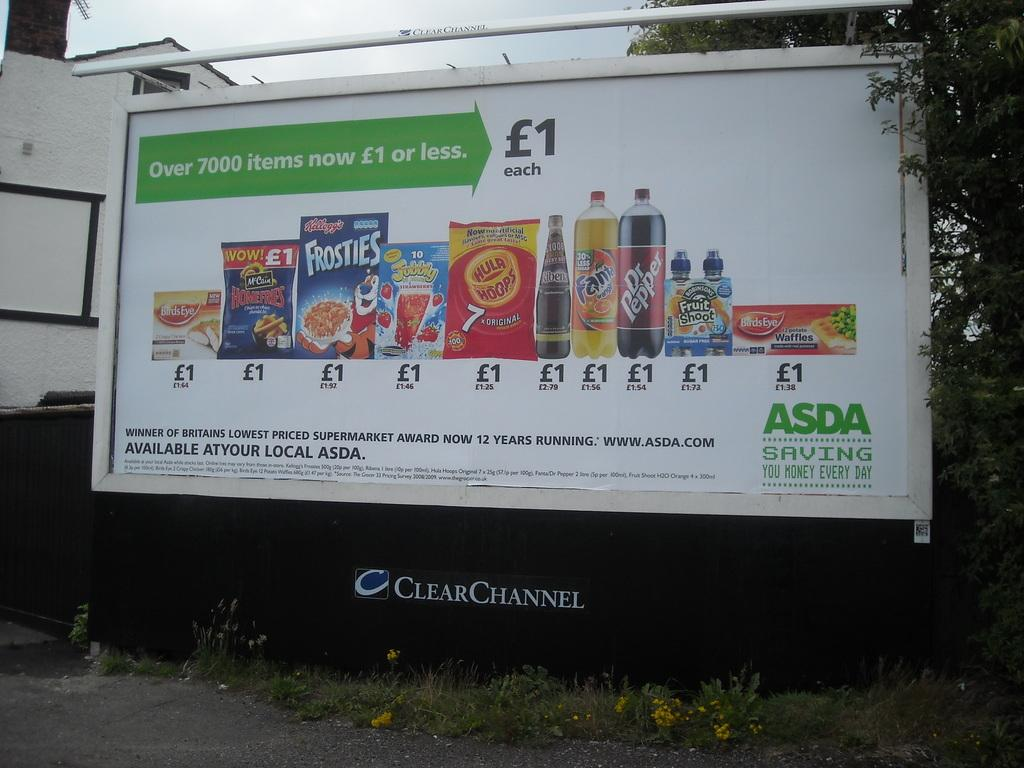<image>
Create a compact narrative representing the image presented. A billboard from ASDA that shows items that are now a dollar or less, items include Fanta and Dr. Pepper among others. 